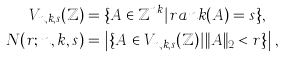<formula> <loc_0><loc_0><loc_500><loc_500>V _ { n , k , s } ( \mathbb { Z } ) & = \{ A \in \mathbb { Z } ^ { n k } | r a n k ( A ) = s \} , \\ N ( r ; n , k , s ) & = \left | \{ A \in V _ { n , k , s } ( \mathbb { Z } ) | \| A \| _ { 2 } < r \} \right | ,</formula> 